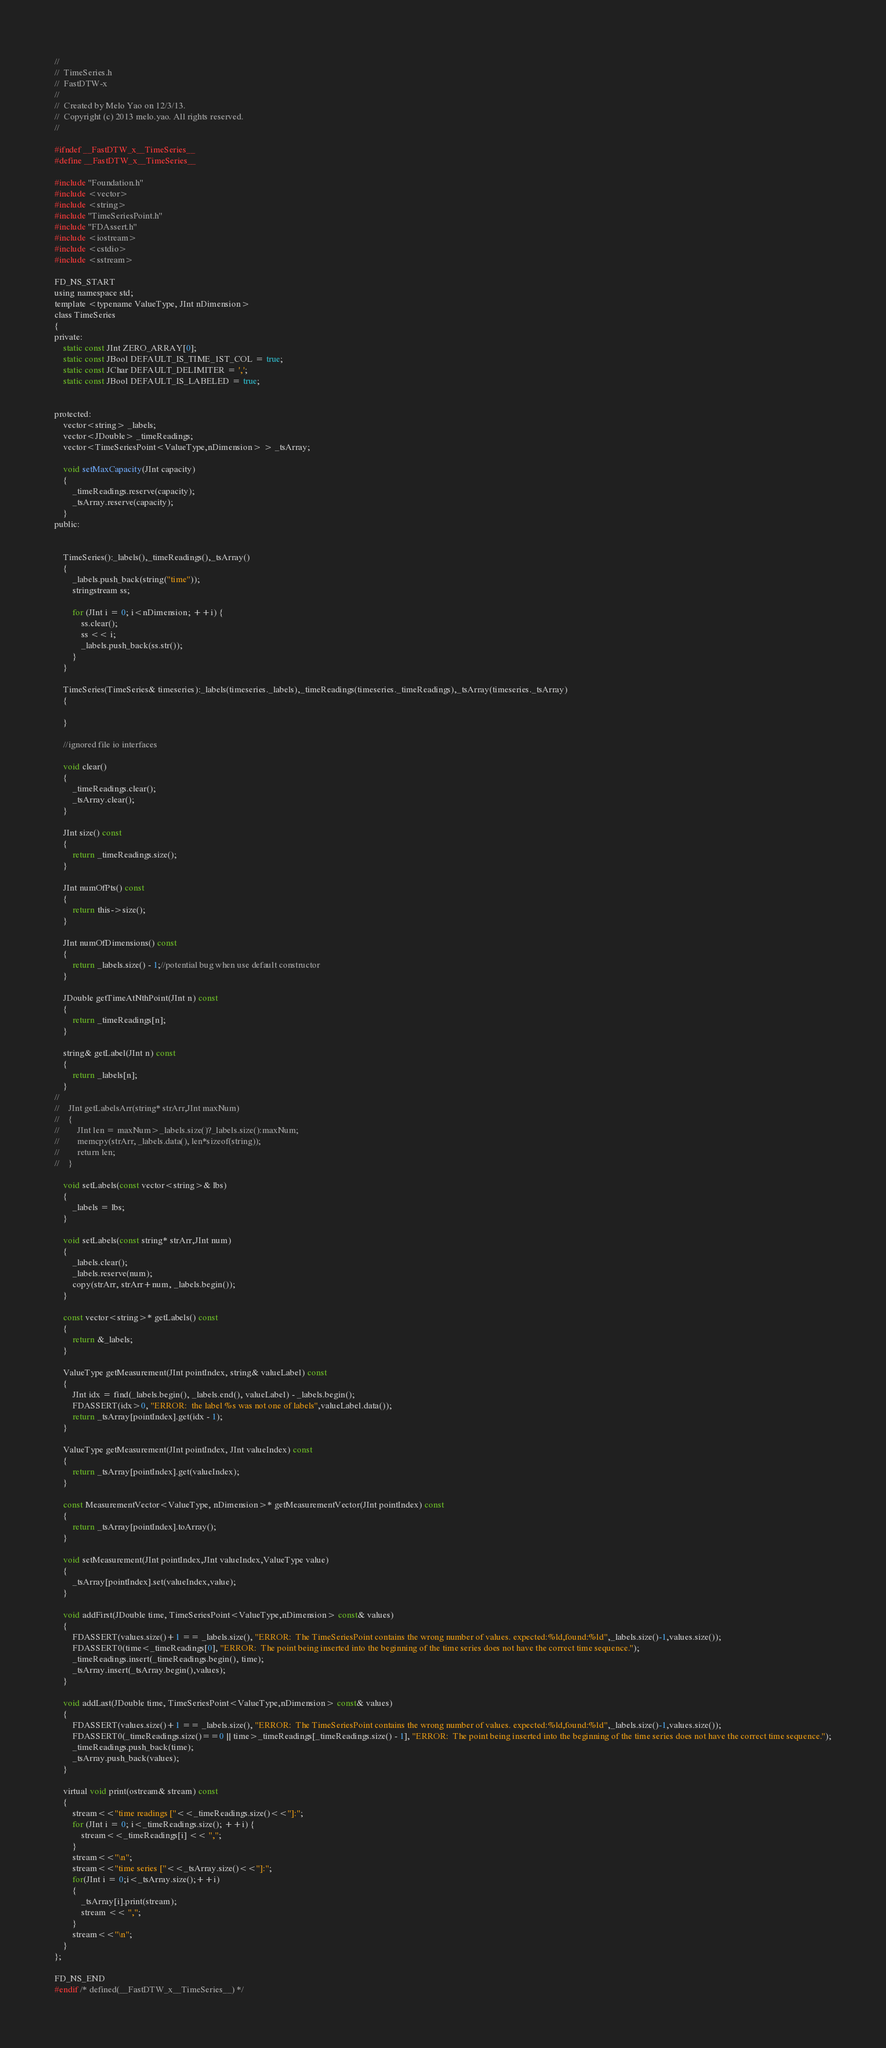<code> <loc_0><loc_0><loc_500><loc_500><_C_>//
//  TimeSeries.h
//  FastDTW-x
//
//  Created by Melo Yao on 12/3/13.
//  Copyright (c) 2013 melo.yao. All rights reserved.
//

#ifndef __FastDTW_x__TimeSeries__
#define __FastDTW_x__TimeSeries__

#include "Foundation.h"
#include <vector>
#include <string>
#include "TimeSeriesPoint.h"
#include "FDAssert.h"
#include <iostream>
#include <cstdio>
#include <sstream>

FD_NS_START
using namespace std;
template <typename ValueType, JInt nDimension>
class TimeSeries
{
private:
    static const JInt ZERO_ARRAY[0];
    static const JBool DEFAULT_IS_TIME_1ST_COL = true;
    static const JChar DEFAULT_DELIMITER = ',';
    static const JBool DEFAULT_IS_LABELED = true;
   
   
protected:
    vector<string> _labels;
    vector<JDouble> _timeReadings;
    vector<TimeSeriesPoint<ValueType,nDimension> > _tsArray;
    
    void setMaxCapacity(JInt capacity)
    {
        _timeReadings.reserve(capacity);
        _tsArray.reserve(capacity);
    }
public:

    
    TimeSeries():_labels(),_timeReadings(),_tsArray()
    {
        _labels.push_back(string("time"));
        stringstream ss;

        for (JInt i = 0; i<nDimension; ++i) {
			ss.clear();
            ss << i;
			_labels.push_back(ss.str());
        }
    }
    
    TimeSeries(TimeSeries& timeseries):_labels(timeseries._labels),_timeReadings(timeseries._timeReadings),_tsArray(timeseries._tsArray)
    {
        
    }
        
    //ignored file io interfaces
    
    void clear()
    {
        _timeReadings.clear();
        _tsArray.clear();
    }
    
    JInt size() const
    {
        return _timeReadings.size();
    }
    
    JInt numOfPts() const
    {
        return this->size();
    }
    
    JInt numOfDimensions() const
    {
        return _labels.size() - 1;//potential bug when use default constructor
    }
    
    JDouble getTimeAtNthPoint(JInt n) const
    {
        return _timeReadings[n];
    }
    
    string& getLabel(JInt n) const
    {
        return _labels[n];
    }
//    
//    JInt getLabelsArr(string* strArr,JInt maxNum)
//    {
//        JInt len = maxNum>_labels.size()?_labels.size():maxNum;
//        memcpy(strArr, _labels.data(), len*sizeof(string));
//        return len;
//    }
    
    void setLabels(const vector<string>& lbs)
    {
        _labels = lbs;
    }
    
    void setLabels(const string* strArr,JInt num)
    {
        _labels.clear();
        _labels.reserve(num);
        copy(strArr, strArr+num, _labels.begin());
    }
    
    const vector<string>* getLabels() const
    {
        return &_labels;
    }
    
    ValueType getMeasurement(JInt pointIndex, string& valueLabel) const
    {
        JInt idx = find(_labels.begin(), _labels.end(), valueLabel) - _labels.begin();
        FDASSERT(idx>0, "ERROR:  the label %s was not one of labels",valueLabel.data());
        return _tsArray[pointIndex].get(idx - 1);
    }
    
    ValueType getMeasurement(JInt pointIndex, JInt valueIndex) const
    {
        return _tsArray[pointIndex].get(valueIndex);
    }
    
    const MeasurementVector<ValueType, nDimension>* getMeasurementVector(JInt pointIndex) const
    {
        return _tsArray[pointIndex].toArray();
    }
    
    void setMeasurement(JInt pointIndex,JInt valueIndex,ValueType value)
    {
        _tsArray[pointIndex].set(valueIndex,value);
    }
    
    void addFirst(JDouble time, TimeSeriesPoint<ValueType,nDimension> const& values)
    {
        FDASSERT(values.size()+1 == _labels.size(), "ERROR:  The TimeSeriesPoint contains the wrong number of values. expected:%ld,found:%ld",_labels.size()-1,values.size());
        FDASSERT0(time<_timeReadings[0], "ERROR:  The point being inserted into the beginning of the time series does not have the correct time sequence.");
        _timeReadings.insert(_timeReadings.begin(), time);
        _tsArray.insert(_tsArray.begin(),values);
    }
    
    void addLast(JDouble time, TimeSeriesPoint<ValueType,nDimension> const& values)
    {
        FDASSERT(values.size()+1 == _labels.size(), "ERROR:  The TimeSeriesPoint contains the wrong number of values. expected:%ld,found:%ld",_labels.size()-1,values.size());
        FDASSERT0(_timeReadings.size()==0 || time>_timeReadings[_timeReadings.size() - 1], "ERROR:  The point being inserted into the beginning of the time series does not have the correct time sequence.");
        _timeReadings.push_back(time);
        _tsArray.push_back(values);
    }
    
    virtual void print(ostream& stream) const
    {
        stream<<"time readings ["<<_timeReadings.size()<<"]:";
        for (JInt i = 0; i<_timeReadings.size(); ++i) {
            stream<<_timeReadings[i] << ",";
        }
        stream<<"\n";
        stream<<"time series ["<<_tsArray.size()<<"]:";
        for(JInt i = 0;i<_tsArray.size();++i)
        {
            _tsArray[i].print(stream);
            stream << ",";
        }
        stream<<"\n";
    }
};

FD_NS_END
#endif /* defined(__FastDTW_x__TimeSeries__) */
</code> 